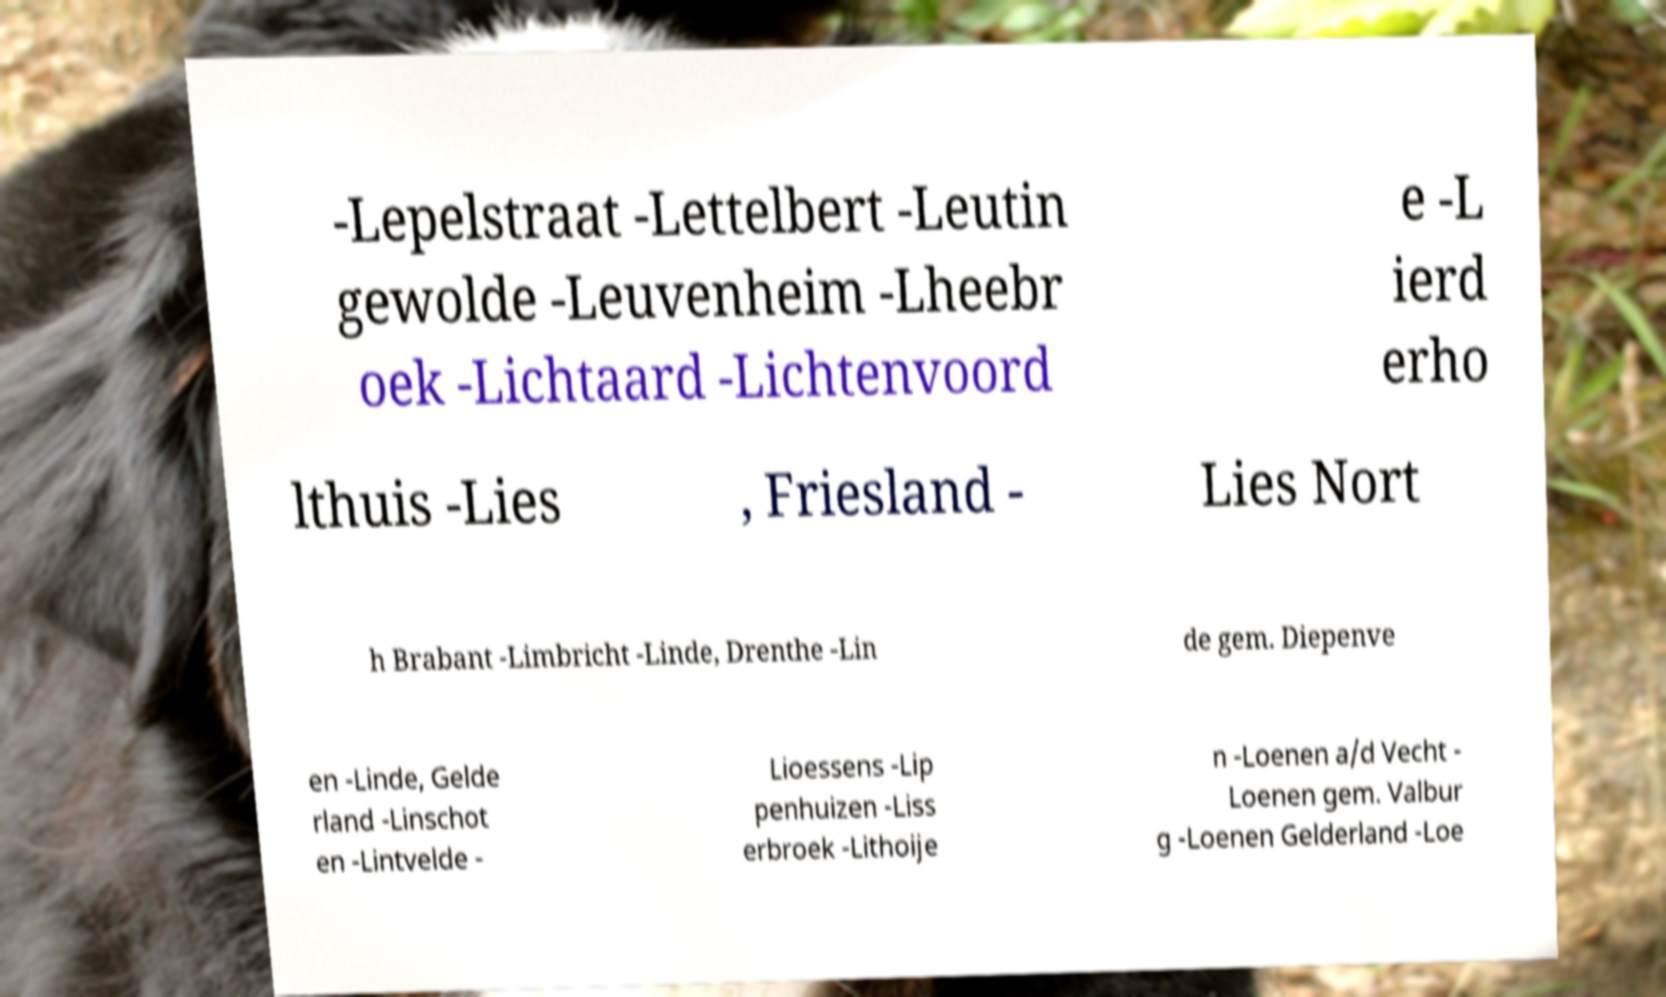There's text embedded in this image that I need extracted. Can you transcribe it verbatim? -Lepelstraat -Lettelbert -Leutin gewolde -Leuvenheim -Lheebr oek -Lichtaard -Lichtenvoord e -L ierd erho lthuis -Lies , Friesland - Lies Nort h Brabant -Limbricht -Linde, Drenthe -Lin de gem. Diepenve en -Linde, Gelde rland -Linschot en -Lintvelde - Lioessens -Lip penhuizen -Liss erbroek -Lithoije n -Loenen a/d Vecht - Loenen gem. Valbur g -Loenen Gelderland -Loe 